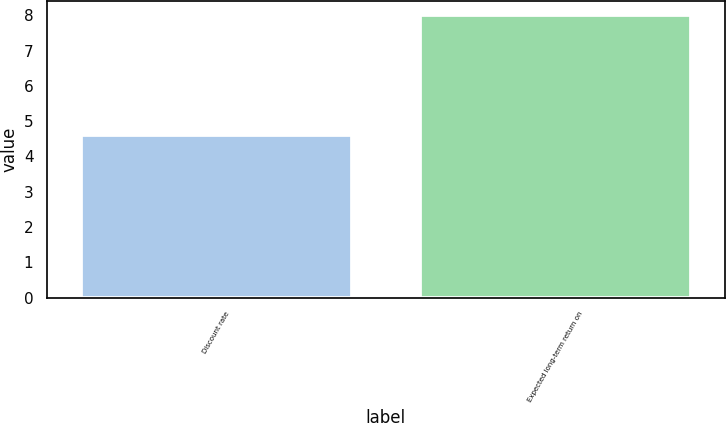<chart> <loc_0><loc_0><loc_500><loc_500><bar_chart><fcel>Discount rate<fcel>Expected long-term return on<nl><fcel>4.6<fcel>8<nl></chart> 